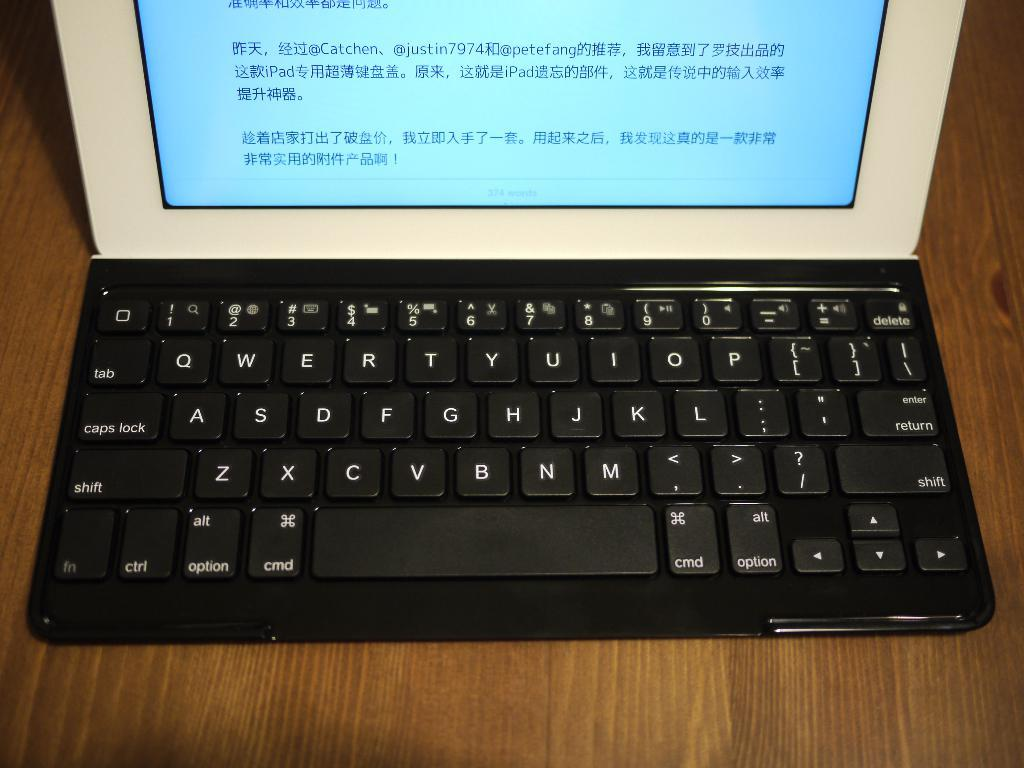Provide a one-sentence caption for the provided image. The laptop has foreign words on the screen. 